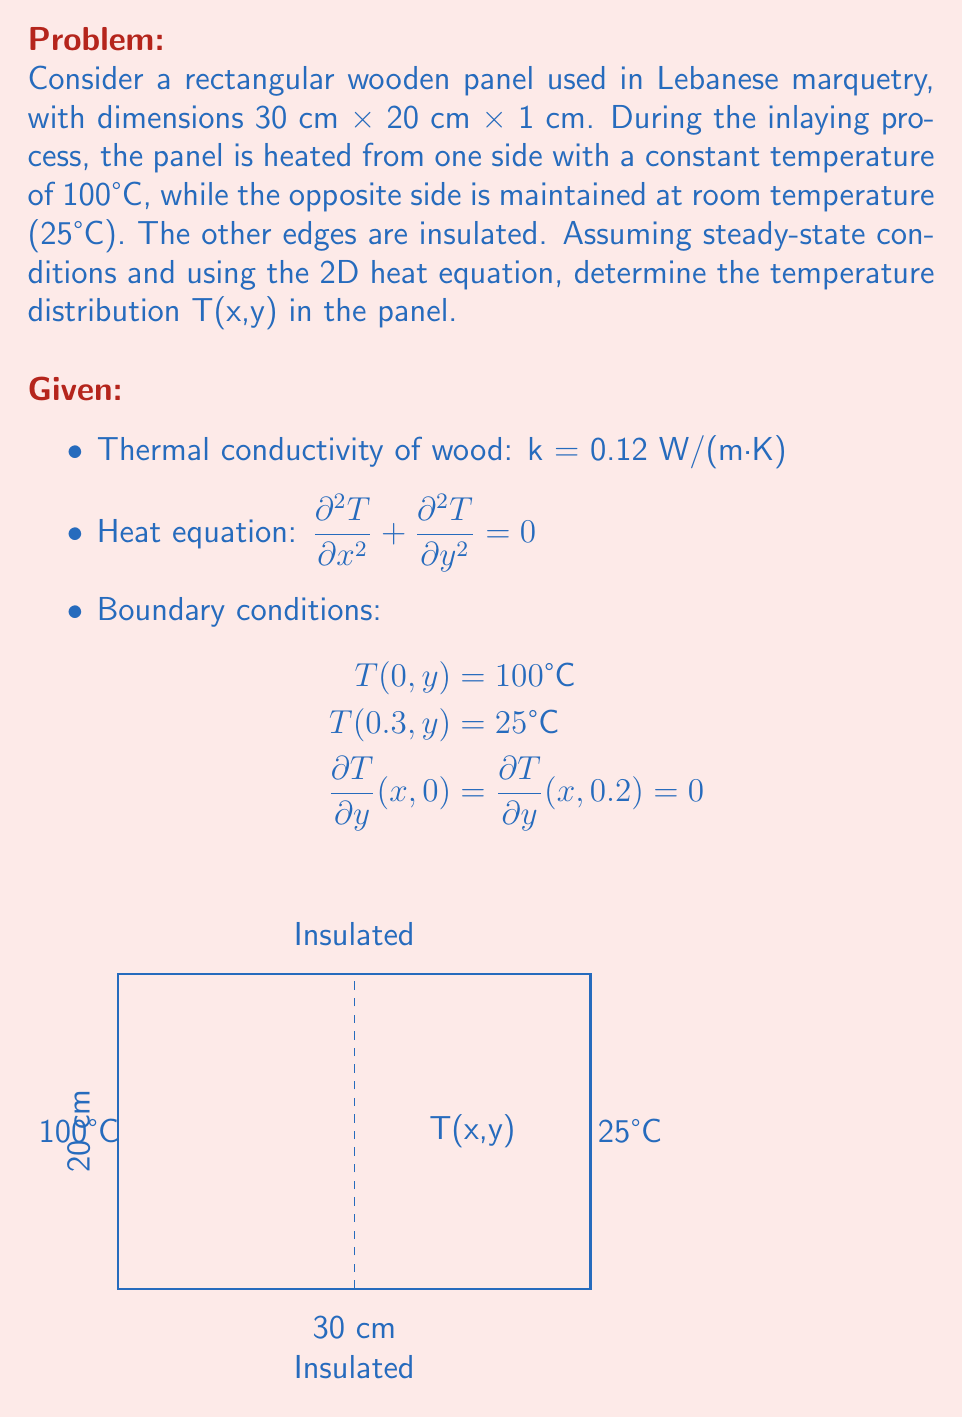Give your solution to this math problem. To solve this 2D heat equation problem, we'll use the separation of variables method:

1) Assume the solution has the form: $$T(x,y) = X(x)Y(y)$$

2) Substituting into the heat equation:
   $$X''(x)Y(y) + X(x)Y''(y) = 0$$
   $$\frac{X''(x)}{X(x)} = -\frac{Y''(y)}{Y(y)} = -\lambda^2$$

3) This gives us two ODEs:
   $$X''(x) + \lambda^2X(x) = 0$$
   $$Y''(y) - \lambda^2Y(y) = 0$$

4) The general solutions are:
   $$X(x) = A \cos(\lambda x) + B \sin(\lambda x)$$
   $$Y(y) = C \cosh(\lambda y) + D \sinh(\lambda y)$$

5) Applying the boundary conditions for Y:
   $$\frac{dY}{dy}(0) = \frac{dY}{dy}(0.2) = 0$$
   This implies D = 0 and $$\lambda = \frac{n\pi}{0.2}, n = 0,1,2,...$$

6) The solution then takes the form:
   $$T(x,y) = \sum_{n=0}^{\infty} (A_n \cos(\frac{n\pi x}{0.2}) + B_n \sin(\frac{n\pi x}{0.2})) \cosh(\frac{n\pi y}{0.2})$$

7) Applying the boundary conditions for X:
   $$T(0,y) = 100 \implies A_0 = 100$$
   $$T(0.3,y) = 25 \implies 100 + \sum_{n=1}^{\infty} A_n \cos(\frac{3n\pi}{2}) = 25$$

8) Using Fourier series expansion:
   $$A_n = \frac{150}{\cosh(\frac{3n\pi}{2})} \sin(\frac{n\pi}{2}), n = 1,3,5,...$$

9) The final solution is:
   $$T(x,y) = 100 - 75\frac{x}{0.3} + \sum_{n=1,3,5,...}^{\infty} \frac{150}{\cosh(\frac{3n\pi}{2})} \sin(\frac{n\pi}{2}) [\cos(\frac{n\pi x}{0.2}) - \cos(\frac{3n\pi}{2})] \cosh(\frac{n\pi y}{0.2})$$
Answer: $$T(x,y) = 100 - 75\frac{x}{0.3} + \sum_{n=1,3,5,...}^{\infty} \frac{150}{\cosh(\frac{3n\pi}{2})} \sin(\frac{n\pi}{2}) [\cos(\frac{n\pi x}{0.2}) - \cos(\frac{3n\pi}{2})] \cosh(\frac{n\pi y}{0.2})$$ 